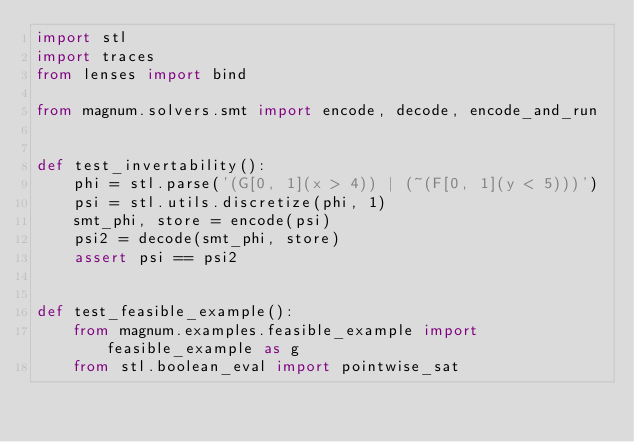<code> <loc_0><loc_0><loc_500><loc_500><_Python_>import stl
import traces
from lenses import bind

from magnum.solvers.smt import encode, decode, encode_and_run


def test_invertability():
    phi = stl.parse('(G[0, 1](x > 4)) | (~(F[0, 1](y < 5)))')
    psi = stl.utils.discretize(phi, 1)
    smt_phi, store = encode(psi)
    psi2 = decode(smt_phi, store)
    assert psi == psi2


def test_feasible_example():
    from magnum.examples.feasible_example import feasible_example as g
    from stl.boolean_eval import pointwise_sat</code> 